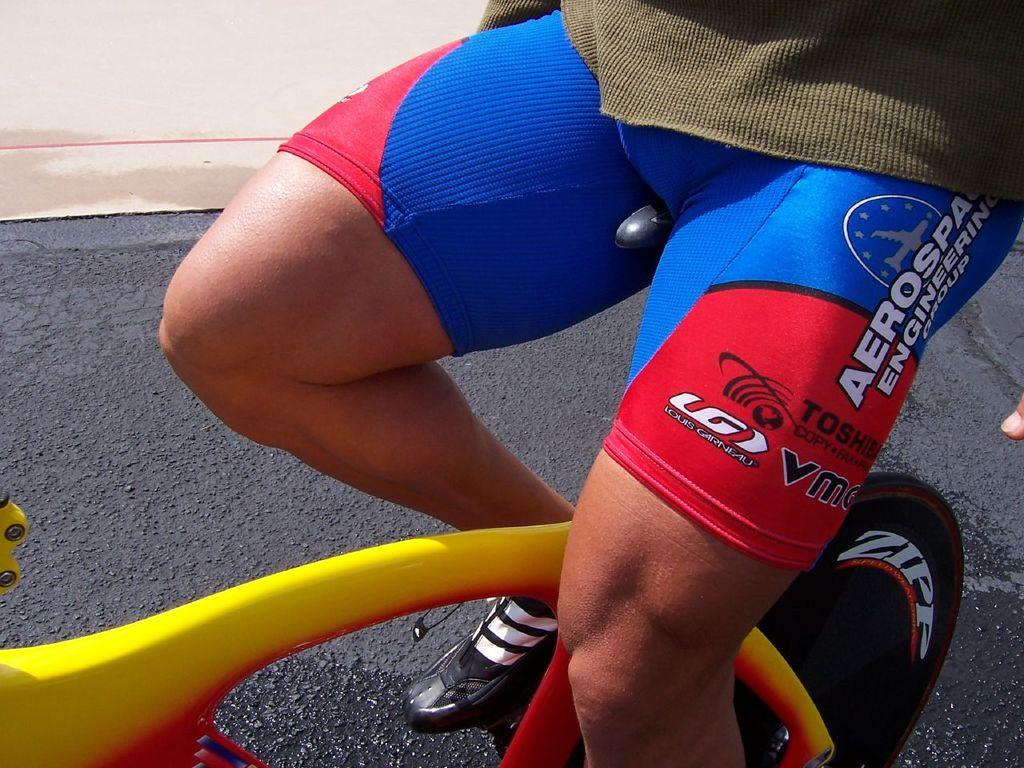Where was the image taken? The image is taken outdoors. What can be seen in the background of the image? There is a wall in the background of the image. What is the person in the image doing? The person is sitting on a bicycle in the middle of the image. What is at the bottom of the image? There is a road at the bottom of the image. What type of net is being used to catch the low-flying birds in the image? There is no net or low-flying birds present in the image. 